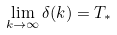<formula> <loc_0><loc_0><loc_500><loc_500>\lim _ { k \rightarrow \infty } \delta ( k ) = T _ { \ast }</formula> 